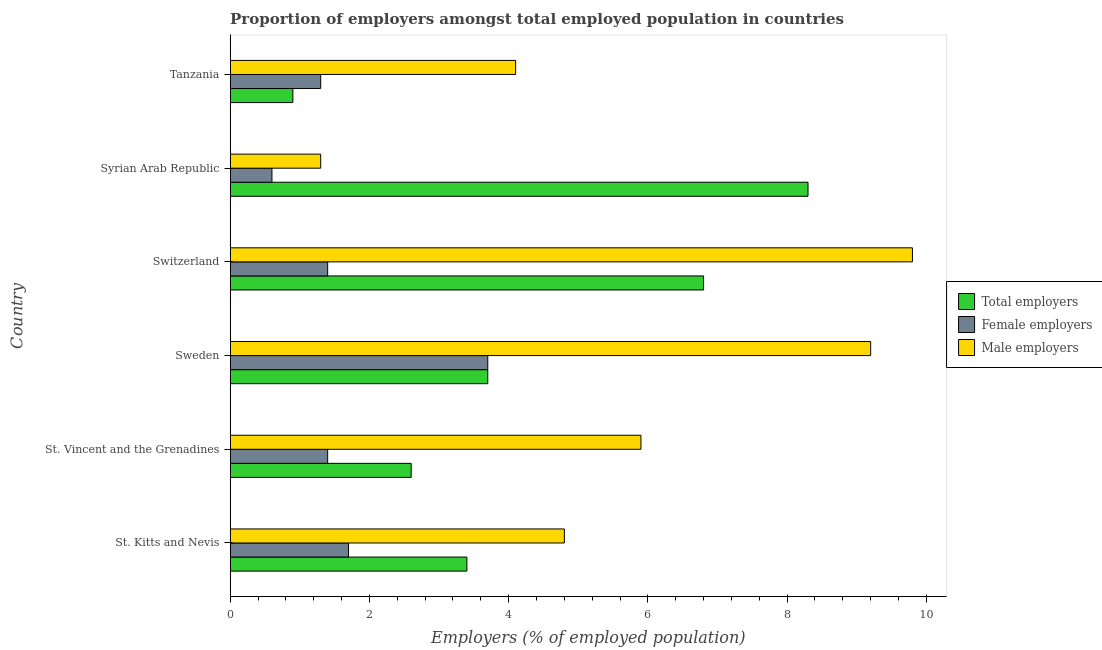How many groups of bars are there?
Keep it short and to the point. 6. How many bars are there on the 4th tick from the top?
Offer a terse response. 3. What is the label of the 6th group of bars from the top?
Provide a succinct answer. St. Kitts and Nevis. In how many cases, is the number of bars for a given country not equal to the number of legend labels?
Offer a terse response. 0. What is the percentage of female employers in St. Kitts and Nevis?
Ensure brevity in your answer.  1.7. Across all countries, what is the maximum percentage of female employers?
Give a very brief answer. 3.7. Across all countries, what is the minimum percentage of male employers?
Make the answer very short. 1.3. In which country was the percentage of female employers maximum?
Offer a terse response. Sweden. In which country was the percentage of female employers minimum?
Offer a terse response. Syrian Arab Republic. What is the total percentage of male employers in the graph?
Your answer should be very brief. 35.1. What is the difference between the percentage of total employers in St. Vincent and the Grenadines and that in Syrian Arab Republic?
Provide a short and direct response. -5.7. What is the difference between the percentage of male employers in St. Kitts and Nevis and the percentage of total employers in St. Vincent and the Grenadines?
Keep it short and to the point. 2.2. What is the average percentage of female employers per country?
Provide a short and direct response. 1.68. What is the difference between the percentage of male employers and percentage of total employers in St. Vincent and the Grenadines?
Give a very brief answer. 3.3. What is the ratio of the percentage of total employers in St. Vincent and the Grenadines to that in Syrian Arab Republic?
Your response must be concise. 0.31. What is the difference between the highest and the second highest percentage of total employers?
Your response must be concise. 1.5. What does the 1st bar from the top in Tanzania represents?
Offer a very short reply. Male employers. What does the 2nd bar from the bottom in St. Vincent and the Grenadines represents?
Your answer should be very brief. Female employers. Is it the case that in every country, the sum of the percentage of total employers and percentage of female employers is greater than the percentage of male employers?
Provide a succinct answer. No. How many bars are there?
Provide a succinct answer. 18. Are all the bars in the graph horizontal?
Your answer should be very brief. Yes. How many countries are there in the graph?
Your answer should be very brief. 6. What is the difference between two consecutive major ticks on the X-axis?
Keep it short and to the point. 2. How many legend labels are there?
Your answer should be compact. 3. How are the legend labels stacked?
Give a very brief answer. Vertical. What is the title of the graph?
Ensure brevity in your answer.  Proportion of employers amongst total employed population in countries. What is the label or title of the X-axis?
Offer a very short reply. Employers (% of employed population). What is the Employers (% of employed population) of Total employers in St. Kitts and Nevis?
Make the answer very short. 3.4. What is the Employers (% of employed population) in Female employers in St. Kitts and Nevis?
Provide a short and direct response. 1.7. What is the Employers (% of employed population) of Male employers in St. Kitts and Nevis?
Your answer should be very brief. 4.8. What is the Employers (% of employed population) of Total employers in St. Vincent and the Grenadines?
Provide a succinct answer. 2.6. What is the Employers (% of employed population) in Female employers in St. Vincent and the Grenadines?
Keep it short and to the point. 1.4. What is the Employers (% of employed population) in Male employers in St. Vincent and the Grenadines?
Ensure brevity in your answer.  5.9. What is the Employers (% of employed population) of Total employers in Sweden?
Make the answer very short. 3.7. What is the Employers (% of employed population) in Female employers in Sweden?
Keep it short and to the point. 3.7. What is the Employers (% of employed population) in Male employers in Sweden?
Give a very brief answer. 9.2. What is the Employers (% of employed population) in Total employers in Switzerland?
Provide a succinct answer. 6.8. What is the Employers (% of employed population) of Female employers in Switzerland?
Offer a very short reply. 1.4. What is the Employers (% of employed population) in Male employers in Switzerland?
Your answer should be compact. 9.8. What is the Employers (% of employed population) in Total employers in Syrian Arab Republic?
Your answer should be compact. 8.3. What is the Employers (% of employed population) of Female employers in Syrian Arab Republic?
Your answer should be very brief. 0.6. What is the Employers (% of employed population) in Male employers in Syrian Arab Republic?
Give a very brief answer. 1.3. What is the Employers (% of employed population) of Total employers in Tanzania?
Keep it short and to the point. 0.9. What is the Employers (% of employed population) of Female employers in Tanzania?
Provide a succinct answer. 1.3. What is the Employers (% of employed population) of Male employers in Tanzania?
Your response must be concise. 4.1. Across all countries, what is the maximum Employers (% of employed population) of Total employers?
Your answer should be compact. 8.3. Across all countries, what is the maximum Employers (% of employed population) in Female employers?
Ensure brevity in your answer.  3.7. Across all countries, what is the maximum Employers (% of employed population) of Male employers?
Make the answer very short. 9.8. Across all countries, what is the minimum Employers (% of employed population) of Total employers?
Your response must be concise. 0.9. Across all countries, what is the minimum Employers (% of employed population) in Female employers?
Your response must be concise. 0.6. Across all countries, what is the minimum Employers (% of employed population) in Male employers?
Offer a terse response. 1.3. What is the total Employers (% of employed population) of Total employers in the graph?
Keep it short and to the point. 25.7. What is the total Employers (% of employed population) of Female employers in the graph?
Offer a terse response. 10.1. What is the total Employers (% of employed population) in Male employers in the graph?
Your answer should be very brief. 35.1. What is the difference between the Employers (% of employed population) in Total employers in St. Kitts and Nevis and that in St. Vincent and the Grenadines?
Your response must be concise. 0.8. What is the difference between the Employers (% of employed population) of Female employers in St. Kitts and Nevis and that in St. Vincent and the Grenadines?
Your answer should be very brief. 0.3. What is the difference between the Employers (% of employed population) in Male employers in St. Kitts and Nevis and that in St. Vincent and the Grenadines?
Give a very brief answer. -1.1. What is the difference between the Employers (% of employed population) in Male employers in St. Kitts and Nevis and that in Sweden?
Your answer should be compact. -4.4. What is the difference between the Employers (% of employed population) in Female employers in St. Kitts and Nevis and that in Switzerland?
Keep it short and to the point. 0.3. What is the difference between the Employers (% of employed population) of Male employers in St. Kitts and Nevis and that in Switzerland?
Keep it short and to the point. -5. What is the difference between the Employers (% of employed population) in Total employers in St. Kitts and Nevis and that in Syrian Arab Republic?
Keep it short and to the point. -4.9. What is the difference between the Employers (% of employed population) of Female employers in St. Vincent and the Grenadines and that in Sweden?
Ensure brevity in your answer.  -2.3. What is the difference between the Employers (% of employed population) of Male employers in St. Vincent and the Grenadines and that in Sweden?
Ensure brevity in your answer.  -3.3. What is the difference between the Employers (% of employed population) in Total employers in St. Vincent and the Grenadines and that in Switzerland?
Your answer should be very brief. -4.2. What is the difference between the Employers (% of employed population) in Male employers in St. Vincent and the Grenadines and that in Switzerland?
Ensure brevity in your answer.  -3.9. What is the difference between the Employers (% of employed population) of Total employers in St. Vincent and the Grenadines and that in Syrian Arab Republic?
Your answer should be very brief. -5.7. What is the difference between the Employers (% of employed population) in Male employers in St. Vincent and the Grenadines and that in Tanzania?
Offer a terse response. 1.8. What is the difference between the Employers (% of employed population) of Female employers in Sweden and that in Switzerland?
Make the answer very short. 2.3. What is the difference between the Employers (% of employed population) in Male employers in Sweden and that in Switzerland?
Your response must be concise. -0.6. What is the difference between the Employers (% of employed population) in Male employers in Sweden and that in Syrian Arab Republic?
Provide a short and direct response. 7.9. What is the difference between the Employers (% of employed population) in Female employers in Sweden and that in Tanzania?
Offer a terse response. 2.4. What is the difference between the Employers (% of employed population) of Male employers in Sweden and that in Tanzania?
Make the answer very short. 5.1. What is the difference between the Employers (% of employed population) in Total employers in Switzerland and that in Tanzania?
Give a very brief answer. 5.9. What is the difference between the Employers (% of employed population) in Female employers in Switzerland and that in Tanzania?
Provide a short and direct response. 0.1. What is the difference between the Employers (% of employed population) of Male employers in Switzerland and that in Tanzania?
Make the answer very short. 5.7. What is the difference between the Employers (% of employed population) in Total employers in Syrian Arab Republic and that in Tanzania?
Provide a succinct answer. 7.4. What is the difference between the Employers (% of employed population) of Total employers in St. Kitts and Nevis and the Employers (% of employed population) of Female employers in St. Vincent and the Grenadines?
Provide a succinct answer. 2. What is the difference between the Employers (% of employed population) of Total employers in St. Kitts and Nevis and the Employers (% of employed population) of Male employers in St. Vincent and the Grenadines?
Your answer should be compact. -2.5. What is the difference between the Employers (% of employed population) of Total employers in St. Kitts and Nevis and the Employers (% of employed population) of Female employers in Sweden?
Keep it short and to the point. -0.3. What is the difference between the Employers (% of employed population) in Female employers in St. Kitts and Nevis and the Employers (% of employed population) in Male employers in Sweden?
Offer a terse response. -7.5. What is the difference between the Employers (% of employed population) in Total employers in St. Kitts and Nevis and the Employers (% of employed population) in Male employers in Switzerland?
Provide a short and direct response. -6.4. What is the difference between the Employers (% of employed population) in Total employers in St. Kitts and Nevis and the Employers (% of employed population) in Male employers in Syrian Arab Republic?
Offer a very short reply. 2.1. What is the difference between the Employers (% of employed population) of Female employers in St. Kitts and Nevis and the Employers (% of employed population) of Male employers in Syrian Arab Republic?
Your answer should be very brief. 0.4. What is the difference between the Employers (% of employed population) in Total employers in St. Vincent and the Grenadines and the Employers (% of employed population) in Male employers in Sweden?
Keep it short and to the point. -6.6. What is the difference between the Employers (% of employed population) of Female employers in St. Vincent and the Grenadines and the Employers (% of employed population) of Male employers in Sweden?
Ensure brevity in your answer.  -7.8. What is the difference between the Employers (% of employed population) in Total employers in St. Vincent and the Grenadines and the Employers (% of employed population) in Female employers in Switzerland?
Ensure brevity in your answer.  1.2. What is the difference between the Employers (% of employed population) in Total employers in St. Vincent and the Grenadines and the Employers (% of employed population) in Female employers in Syrian Arab Republic?
Ensure brevity in your answer.  2. What is the difference between the Employers (% of employed population) of Total employers in St. Vincent and the Grenadines and the Employers (% of employed population) of Male employers in Syrian Arab Republic?
Keep it short and to the point. 1.3. What is the difference between the Employers (% of employed population) in Total employers in St. Vincent and the Grenadines and the Employers (% of employed population) in Female employers in Tanzania?
Offer a terse response. 1.3. What is the difference between the Employers (% of employed population) in Total employers in St. Vincent and the Grenadines and the Employers (% of employed population) in Male employers in Tanzania?
Make the answer very short. -1.5. What is the difference between the Employers (% of employed population) in Total employers in Sweden and the Employers (% of employed population) in Female employers in Switzerland?
Your response must be concise. 2.3. What is the difference between the Employers (% of employed population) in Total employers in Sweden and the Employers (% of employed population) in Male employers in Switzerland?
Keep it short and to the point. -6.1. What is the difference between the Employers (% of employed population) of Total employers in Sweden and the Employers (% of employed population) of Female employers in Syrian Arab Republic?
Give a very brief answer. 3.1. What is the difference between the Employers (% of employed population) of Total employers in Sweden and the Employers (% of employed population) of Male employers in Syrian Arab Republic?
Your answer should be very brief. 2.4. What is the difference between the Employers (% of employed population) of Female employers in Sweden and the Employers (% of employed population) of Male employers in Syrian Arab Republic?
Make the answer very short. 2.4. What is the difference between the Employers (% of employed population) in Total employers in Sweden and the Employers (% of employed population) in Male employers in Tanzania?
Provide a succinct answer. -0.4. What is the difference between the Employers (% of employed population) of Female employers in Switzerland and the Employers (% of employed population) of Male employers in Syrian Arab Republic?
Give a very brief answer. 0.1. What is the difference between the Employers (% of employed population) of Total employers in Switzerland and the Employers (% of employed population) of Female employers in Tanzania?
Provide a short and direct response. 5.5. What is the difference between the Employers (% of employed population) of Female employers in Switzerland and the Employers (% of employed population) of Male employers in Tanzania?
Ensure brevity in your answer.  -2.7. What is the difference between the Employers (% of employed population) in Total employers in Syrian Arab Republic and the Employers (% of employed population) in Female employers in Tanzania?
Ensure brevity in your answer.  7. What is the difference between the Employers (% of employed population) of Female employers in Syrian Arab Republic and the Employers (% of employed population) of Male employers in Tanzania?
Keep it short and to the point. -3.5. What is the average Employers (% of employed population) of Total employers per country?
Make the answer very short. 4.28. What is the average Employers (% of employed population) of Female employers per country?
Keep it short and to the point. 1.68. What is the average Employers (% of employed population) of Male employers per country?
Keep it short and to the point. 5.85. What is the difference between the Employers (% of employed population) in Total employers and Employers (% of employed population) in Female employers in St. Kitts and Nevis?
Offer a very short reply. 1.7. What is the difference between the Employers (% of employed population) of Total employers and Employers (% of employed population) of Male employers in St. Kitts and Nevis?
Provide a short and direct response. -1.4. What is the difference between the Employers (% of employed population) of Female employers and Employers (% of employed population) of Male employers in St. Kitts and Nevis?
Ensure brevity in your answer.  -3.1. What is the difference between the Employers (% of employed population) of Total employers and Employers (% of employed population) of Female employers in St. Vincent and the Grenadines?
Your answer should be compact. 1.2. What is the difference between the Employers (% of employed population) in Female employers and Employers (% of employed population) in Male employers in St. Vincent and the Grenadines?
Ensure brevity in your answer.  -4.5. What is the difference between the Employers (% of employed population) in Total employers and Employers (% of employed population) in Female employers in Sweden?
Ensure brevity in your answer.  0. What is the difference between the Employers (% of employed population) of Female employers and Employers (% of employed population) of Male employers in Sweden?
Make the answer very short. -5.5. What is the difference between the Employers (% of employed population) of Total employers and Employers (% of employed population) of Female employers in Switzerland?
Give a very brief answer. 5.4. What is the difference between the Employers (% of employed population) of Total employers and Employers (% of employed population) of Male employers in Switzerland?
Offer a terse response. -3. What is the difference between the Employers (% of employed population) of Total employers and Employers (% of employed population) of Female employers in Syrian Arab Republic?
Give a very brief answer. 7.7. What is the difference between the Employers (% of employed population) in Total employers and Employers (% of employed population) in Male employers in Syrian Arab Republic?
Offer a very short reply. 7. What is the difference between the Employers (% of employed population) of Female employers and Employers (% of employed population) of Male employers in Syrian Arab Republic?
Ensure brevity in your answer.  -0.7. What is the difference between the Employers (% of employed population) in Total employers and Employers (% of employed population) in Male employers in Tanzania?
Your response must be concise. -3.2. What is the ratio of the Employers (% of employed population) in Total employers in St. Kitts and Nevis to that in St. Vincent and the Grenadines?
Make the answer very short. 1.31. What is the ratio of the Employers (% of employed population) in Female employers in St. Kitts and Nevis to that in St. Vincent and the Grenadines?
Make the answer very short. 1.21. What is the ratio of the Employers (% of employed population) in Male employers in St. Kitts and Nevis to that in St. Vincent and the Grenadines?
Ensure brevity in your answer.  0.81. What is the ratio of the Employers (% of employed population) of Total employers in St. Kitts and Nevis to that in Sweden?
Keep it short and to the point. 0.92. What is the ratio of the Employers (% of employed population) of Female employers in St. Kitts and Nevis to that in Sweden?
Give a very brief answer. 0.46. What is the ratio of the Employers (% of employed population) in Male employers in St. Kitts and Nevis to that in Sweden?
Provide a short and direct response. 0.52. What is the ratio of the Employers (% of employed population) in Female employers in St. Kitts and Nevis to that in Switzerland?
Ensure brevity in your answer.  1.21. What is the ratio of the Employers (% of employed population) of Male employers in St. Kitts and Nevis to that in Switzerland?
Provide a succinct answer. 0.49. What is the ratio of the Employers (% of employed population) of Total employers in St. Kitts and Nevis to that in Syrian Arab Republic?
Provide a succinct answer. 0.41. What is the ratio of the Employers (% of employed population) of Female employers in St. Kitts and Nevis to that in Syrian Arab Republic?
Offer a very short reply. 2.83. What is the ratio of the Employers (% of employed population) in Male employers in St. Kitts and Nevis to that in Syrian Arab Republic?
Your answer should be compact. 3.69. What is the ratio of the Employers (% of employed population) in Total employers in St. Kitts and Nevis to that in Tanzania?
Keep it short and to the point. 3.78. What is the ratio of the Employers (% of employed population) of Female employers in St. Kitts and Nevis to that in Tanzania?
Ensure brevity in your answer.  1.31. What is the ratio of the Employers (% of employed population) in Male employers in St. Kitts and Nevis to that in Tanzania?
Make the answer very short. 1.17. What is the ratio of the Employers (% of employed population) of Total employers in St. Vincent and the Grenadines to that in Sweden?
Provide a succinct answer. 0.7. What is the ratio of the Employers (% of employed population) of Female employers in St. Vincent and the Grenadines to that in Sweden?
Your answer should be compact. 0.38. What is the ratio of the Employers (% of employed population) in Male employers in St. Vincent and the Grenadines to that in Sweden?
Give a very brief answer. 0.64. What is the ratio of the Employers (% of employed population) of Total employers in St. Vincent and the Grenadines to that in Switzerland?
Your answer should be compact. 0.38. What is the ratio of the Employers (% of employed population) of Male employers in St. Vincent and the Grenadines to that in Switzerland?
Provide a succinct answer. 0.6. What is the ratio of the Employers (% of employed population) of Total employers in St. Vincent and the Grenadines to that in Syrian Arab Republic?
Keep it short and to the point. 0.31. What is the ratio of the Employers (% of employed population) in Female employers in St. Vincent and the Grenadines to that in Syrian Arab Republic?
Offer a very short reply. 2.33. What is the ratio of the Employers (% of employed population) of Male employers in St. Vincent and the Grenadines to that in Syrian Arab Republic?
Provide a succinct answer. 4.54. What is the ratio of the Employers (% of employed population) in Total employers in St. Vincent and the Grenadines to that in Tanzania?
Offer a terse response. 2.89. What is the ratio of the Employers (% of employed population) of Female employers in St. Vincent and the Grenadines to that in Tanzania?
Offer a very short reply. 1.08. What is the ratio of the Employers (% of employed population) in Male employers in St. Vincent and the Grenadines to that in Tanzania?
Provide a short and direct response. 1.44. What is the ratio of the Employers (% of employed population) in Total employers in Sweden to that in Switzerland?
Your answer should be compact. 0.54. What is the ratio of the Employers (% of employed population) in Female employers in Sweden to that in Switzerland?
Ensure brevity in your answer.  2.64. What is the ratio of the Employers (% of employed population) of Male employers in Sweden to that in Switzerland?
Give a very brief answer. 0.94. What is the ratio of the Employers (% of employed population) in Total employers in Sweden to that in Syrian Arab Republic?
Provide a succinct answer. 0.45. What is the ratio of the Employers (% of employed population) of Female employers in Sweden to that in Syrian Arab Republic?
Give a very brief answer. 6.17. What is the ratio of the Employers (% of employed population) in Male employers in Sweden to that in Syrian Arab Republic?
Make the answer very short. 7.08. What is the ratio of the Employers (% of employed population) in Total employers in Sweden to that in Tanzania?
Keep it short and to the point. 4.11. What is the ratio of the Employers (% of employed population) in Female employers in Sweden to that in Tanzania?
Your answer should be very brief. 2.85. What is the ratio of the Employers (% of employed population) of Male employers in Sweden to that in Tanzania?
Give a very brief answer. 2.24. What is the ratio of the Employers (% of employed population) of Total employers in Switzerland to that in Syrian Arab Republic?
Provide a short and direct response. 0.82. What is the ratio of the Employers (% of employed population) in Female employers in Switzerland to that in Syrian Arab Republic?
Ensure brevity in your answer.  2.33. What is the ratio of the Employers (% of employed population) of Male employers in Switzerland to that in Syrian Arab Republic?
Ensure brevity in your answer.  7.54. What is the ratio of the Employers (% of employed population) in Total employers in Switzerland to that in Tanzania?
Offer a very short reply. 7.56. What is the ratio of the Employers (% of employed population) of Female employers in Switzerland to that in Tanzania?
Give a very brief answer. 1.08. What is the ratio of the Employers (% of employed population) of Male employers in Switzerland to that in Tanzania?
Offer a terse response. 2.39. What is the ratio of the Employers (% of employed population) in Total employers in Syrian Arab Republic to that in Tanzania?
Make the answer very short. 9.22. What is the ratio of the Employers (% of employed population) of Female employers in Syrian Arab Republic to that in Tanzania?
Provide a succinct answer. 0.46. What is the ratio of the Employers (% of employed population) in Male employers in Syrian Arab Republic to that in Tanzania?
Ensure brevity in your answer.  0.32. What is the difference between the highest and the second highest Employers (% of employed population) in Female employers?
Ensure brevity in your answer.  2. What is the difference between the highest and the second highest Employers (% of employed population) in Male employers?
Your answer should be very brief. 0.6. What is the difference between the highest and the lowest Employers (% of employed population) of Female employers?
Offer a terse response. 3.1. What is the difference between the highest and the lowest Employers (% of employed population) of Male employers?
Offer a terse response. 8.5. 